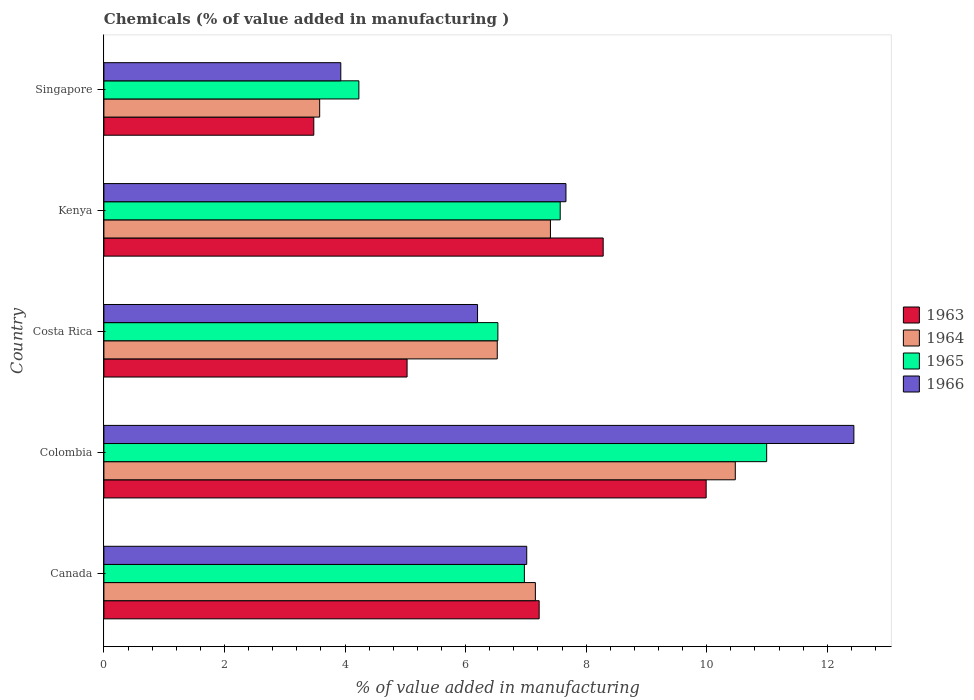How many different coloured bars are there?
Make the answer very short. 4. Are the number of bars on each tick of the Y-axis equal?
Ensure brevity in your answer.  Yes. How many bars are there on the 4th tick from the top?
Give a very brief answer. 4. What is the label of the 1st group of bars from the top?
Give a very brief answer. Singapore. In how many cases, is the number of bars for a given country not equal to the number of legend labels?
Offer a terse response. 0. What is the value added in manufacturing chemicals in 1964 in Kenya?
Offer a terse response. 7.41. Across all countries, what is the maximum value added in manufacturing chemicals in 1966?
Ensure brevity in your answer.  12.44. Across all countries, what is the minimum value added in manufacturing chemicals in 1963?
Provide a short and direct response. 3.48. In which country was the value added in manufacturing chemicals in 1965 minimum?
Your answer should be very brief. Singapore. What is the total value added in manufacturing chemicals in 1963 in the graph?
Give a very brief answer. 34.01. What is the difference between the value added in manufacturing chemicals in 1964 in Canada and that in Costa Rica?
Your answer should be compact. 0.63. What is the difference between the value added in manufacturing chemicals in 1963 in Colombia and the value added in manufacturing chemicals in 1965 in Canada?
Make the answer very short. 3.02. What is the average value added in manufacturing chemicals in 1964 per country?
Make the answer very short. 7.03. What is the difference between the value added in manufacturing chemicals in 1963 and value added in manufacturing chemicals in 1964 in Canada?
Your answer should be very brief. 0.06. In how many countries, is the value added in manufacturing chemicals in 1966 greater than 4 %?
Provide a succinct answer. 4. What is the ratio of the value added in manufacturing chemicals in 1966 in Costa Rica to that in Kenya?
Give a very brief answer. 0.81. Is the value added in manufacturing chemicals in 1964 in Canada less than that in Singapore?
Ensure brevity in your answer.  No. What is the difference between the highest and the second highest value added in manufacturing chemicals in 1963?
Ensure brevity in your answer.  1.71. What is the difference between the highest and the lowest value added in manufacturing chemicals in 1963?
Your response must be concise. 6.51. Is the sum of the value added in manufacturing chemicals in 1966 in Canada and Kenya greater than the maximum value added in manufacturing chemicals in 1963 across all countries?
Offer a terse response. Yes. Is it the case that in every country, the sum of the value added in manufacturing chemicals in 1963 and value added in manufacturing chemicals in 1965 is greater than the sum of value added in manufacturing chemicals in 1966 and value added in manufacturing chemicals in 1964?
Provide a succinct answer. No. What does the 2nd bar from the top in Canada represents?
Your answer should be very brief. 1965. What does the 4th bar from the bottom in Costa Rica represents?
Give a very brief answer. 1966. How many bars are there?
Your answer should be very brief. 20. How many countries are there in the graph?
Ensure brevity in your answer.  5. Are the values on the major ticks of X-axis written in scientific E-notation?
Keep it short and to the point. No. Does the graph contain any zero values?
Give a very brief answer. No. How are the legend labels stacked?
Make the answer very short. Vertical. What is the title of the graph?
Ensure brevity in your answer.  Chemicals (% of value added in manufacturing ). Does "1972" appear as one of the legend labels in the graph?
Your answer should be very brief. No. What is the label or title of the X-axis?
Keep it short and to the point. % of value added in manufacturing. What is the % of value added in manufacturing in 1963 in Canada?
Keep it short and to the point. 7.22. What is the % of value added in manufacturing in 1964 in Canada?
Your response must be concise. 7.16. What is the % of value added in manufacturing in 1965 in Canada?
Give a very brief answer. 6.98. What is the % of value added in manufacturing in 1966 in Canada?
Provide a short and direct response. 7.01. What is the % of value added in manufacturing in 1963 in Colombia?
Make the answer very short. 9.99. What is the % of value added in manufacturing in 1964 in Colombia?
Keep it short and to the point. 10.47. What is the % of value added in manufacturing of 1965 in Colombia?
Make the answer very short. 10.99. What is the % of value added in manufacturing in 1966 in Colombia?
Your answer should be compact. 12.44. What is the % of value added in manufacturing of 1963 in Costa Rica?
Provide a short and direct response. 5.03. What is the % of value added in manufacturing of 1964 in Costa Rica?
Keep it short and to the point. 6.53. What is the % of value added in manufacturing of 1965 in Costa Rica?
Your response must be concise. 6.54. What is the % of value added in manufacturing of 1966 in Costa Rica?
Make the answer very short. 6.2. What is the % of value added in manufacturing in 1963 in Kenya?
Keep it short and to the point. 8.28. What is the % of value added in manufacturing of 1964 in Kenya?
Provide a succinct answer. 7.41. What is the % of value added in manufacturing of 1965 in Kenya?
Provide a short and direct response. 7.57. What is the % of value added in manufacturing in 1966 in Kenya?
Provide a short and direct response. 7.67. What is the % of value added in manufacturing in 1963 in Singapore?
Make the answer very short. 3.48. What is the % of value added in manufacturing in 1964 in Singapore?
Make the answer very short. 3.58. What is the % of value added in manufacturing of 1965 in Singapore?
Your response must be concise. 4.23. What is the % of value added in manufacturing of 1966 in Singapore?
Your answer should be compact. 3.93. Across all countries, what is the maximum % of value added in manufacturing of 1963?
Ensure brevity in your answer.  9.99. Across all countries, what is the maximum % of value added in manufacturing of 1964?
Your answer should be very brief. 10.47. Across all countries, what is the maximum % of value added in manufacturing in 1965?
Your answer should be very brief. 10.99. Across all countries, what is the maximum % of value added in manufacturing of 1966?
Your answer should be very brief. 12.44. Across all countries, what is the minimum % of value added in manufacturing in 1963?
Ensure brevity in your answer.  3.48. Across all countries, what is the minimum % of value added in manufacturing of 1964?
Offer a terse response. 3.58. Across all countries, what is the minimum % of value added in manufacturing in 1965?
Provide a short and direct response. 4.23. Across all countries, what is the minimum % of value added in manufacturing of 1966?
Your response must be concise. 3.93. What is the total % of value added in manufacturing in 1963 in the graph?
Your answer should be compact. 34.01. What is the total % of value added in manufacturing in 1964 in the graph?
Make the answer very short. 35.15. What is the total % of value added in manufacturing of 1965 in the graph?
Provide a succinct answer. 36.31. What is the total % of value added in manufacturing in 1966 in the graph?
Make the answer very short. 37.25. What is the difference between the % of value added in manufacturing of 1963 in Canada and that in Colombia?
Ensure brevity in your answer.  -2.77. What is the difference between the % of value added in manufacturing of 1964 in Canada and that in Colombia?
Ensure brevity in your answer.  -3.32. What is the difference between the % of value added in manufacturing of 1965 in Canada and that in Colombia?
Keep it short and to the point. -4.02. What is the difference between the % of value added in manufacturing of 1966 in Canada and that in Colombia?
Offer a terse response. -5.43. What is the difference between the % of value added in manufacturing of 1963 in Canada and that in Costa Rica?
Provide a short and direct response. 2.19. What is the difference between the % of value added in manufacturing in 1964 in Canada and that in Costa Rica?
Keep it short and to the point. 0.63. What is the difference between the % of value added in manufacturing in 1965 in Canada and that in Costa Rica?
Your answer should be compact. 0.44. What is the difference between the % of value added in manufacturing in 1966 in Canada and that in Costa Rica?
Offer a terse response. 0.82. What is the difference between the % of value added in manufacturing of 1963 in Canada and that in Kenya?
Keep it short and to the point. -1.06. What is the difference between the % of value added in manufacturing of 1964 in Canada and that in Kenya?
Your answer should be compact. -0.25. What is the difference between the % of value added in manufacturing in 1965 in Canada and that in Kenya?
Your answer should be very brief. -0.59. What is the difference between the % of value added in manufacturing in 1966 in Canada and that in Kenya?
Offer a terse response. -0.65. What is the difference between the % of value added in manufacturing in 1963 in Canada and that in Singapore?
Your answer should be very brief. 3.74. What is the difference between the % of value added in manufacturing of 1964 in Canada and that in Singapore?
Provide a short and direct response. 3.58. What is the difference between the % of value added in manufacturing of 1965 in Canada and that in Singapore?
Give a very brief answer. 2.75. What is the difference between the % of value added in manufacturing in 1966 in Canada and that in Singapore?
Provide a succinct answer. 3.08. What is the difference between the % of value added in manufacturing in 1963 in Colombia and that in Costa Rica?
Give a very brief answer. 4.96. What is the difference between the % of value added in manufacturing of 1964 in Colombia and that in Costa Rica?
Offer a very short reply. 3.95. What is the difference between the % of value added in manufacturing of 1965 in Colombia and that in Costa Rica?
Your answer should be compact. 4.46. What is the difference between the % of value added in manufacturing in 1966 in Colombia and that in Costa Rica?
Provide a succinct answer. 6.24. What is the difference between the % of value added in manufacturing in 1963 in Colombia and that in Kenya?
Keep it short and to the point. 1.71. What is the difference between the % of value added in manufacturing in 1964 in Colombia and that in Kenya?
Provide a succinct answer. 3.07. What is the difference between the % of value added in manufacturing of 1965 in Colombia and that in Kenya?
Provide a succinct answer. 3.43. What is the difference between the % of value added in manufacturing in 1966 in Colombia and that in Kenya?
Your answer should be compact. 4.78. What is the difference between the % of value added in manufacturing in 1963 in Colombia and that in Singapore?
Give a very brief answer. 6.51. What is the difference between the % of value added in manufacturing of 1964 in Colombia and that in Singapore?
Keep it short and to the point. 6.89. What is the difference between the % of value added in manufacturing in 1965 in Colombia and that in Singapore?
Keep it short and to the point. 6.76. What is the difference between the % of value added in manufacturing in 1966 in Colombia and that in Singapore?
Your response must be concise. 8.51. What is the difference between the % of value added in manufacturing of 1963 in Costa Rica and that in Kenya?
Make the answer very short. -3.25. What is the difference between the % of value added in manufacturing of 1964 in Costa Rica and that in Kenya?
Your response must be concise. -0.88. What is the difference between the % of value added in manufacturing of 1965 in Costa Rica and that in Kenya?
Your response must be concise. -1.03. What is the difference between the % of value added in manufacturing in 1966 in Costa Rica and that in Kenya?
Offer a very short reply. -1.47. What is the difference between the % of value added in manufacturing in 1963 in Costa Rica and that in Singapore?
Your response must be concise. 1.55. What is the difference between the % of value added in manufacturing of 1964 in Costa Rica and that in Singapore?
Provide a short and direct response. 2.95. What is the difference between the % of value added in manufacturing in 1965 in Costa Rica and that in Singapore?
Your answer should be compact. 2.31. What is the difference between the % of value added in manufacturing in 1966 in Costa Rica and that in Singapore?
Ensure brevity in your answer.  2.27. What is the difference between the % of value added in manufacturing in 1963 in Kenya and that in Singapore?
Give a very brief answer. 4.8. What is the difference between the % of value added in manufacturing in 1964 in Kenya and that in Singapore?
Provide a succinct answer. 3.83. What is the difference between the % of value added in manufacturing of 1965 in Kenya and that in Singapore?
Ensure brevity in your answer.  3.34. What is the difference between the % of value added in manufacturing of 1966 in Kenya and that in Singapore?
Offer a terse response. 3.74. What is the difference between the % of value added in manufacturing in 1963 in Canada and the % of value added in manufacturing in 1964 in Colombia?
Provide a short and direct response. -3.25. What is the difference between the % of value added in manufacturing of 1963 in Canada and the % of value added in manufacturing of 1965 in Colombia?
Offer a terse response. -3.77. What is the difference between the % of value added in manufacturing of 1963 in Canada and the % of value added in manufacturing of 1966 in Colombia?
Offer a very short reply. -5.22. What is the difference between the % of value added in manufacturing of 1964 in Canada and the % of value added in manufacturing of 1965 in Colombia?
Ensure brevity in your answer.  -3.84. What is the difference between the % of value added in manufacturing in 1964 in Canada and the % of value added in manufacturing in 1966 in Colombia?
Provide a short and direct response. -5.28. What is the difference between the % of value added in manufacturing in 1965 in Canada and the % of value added in manufacturing in 1966 in Colombia?
Offer a very short reply. -5.47. What is the difference between the % of value added in manufacturing of 1963 in Canada and the % of value added in manufacturing of 1964 in Costa Rica?
Ensure brevity in your answer.  0.69. What is the difference between the % of value added in manufacturing in 1963 in Canada and the % of value added in manufacturing in 1965 in Costa Rica?
Your response must be concise. 0.68. What is the difference between the % of value added in manufacturing of 1963 in Canada and the % of value added in manufacturing of 1966 in Costa Rica?
Ensure brevity in your answer.  1.02. What is the difference between the % of value added in manufacturing of 1964 in Canada and the % of value added in manufacturing of 1965 in Costa Rica?
Provide a succinct answer. 0.62. What is the difference between the % of value added in manufacturing of 1964 in Canada and the % of value added in manufacturing of 1966 in Costa Rica?
Your response must be concise. 0.96. What is the difference between the % of value added in manufacturing of 1965 in Canada and the % of value added in manufacturing of 1966 in Costa Rica?
Ensure brevity in your answer.  0.78. What is the difference between the % of value added in manufacturing of 1963 in Canada and the % of value added in manufacturing of 1964 in Kenya?
Give a very brief answer. -0.19. What is the difference between the % of value added in manufacturing in 1963 in Canada and the % of value added in manufacturing in 1965 in Kenya?
Your answer should be very brief. -0.35. What is the difference between the % of value added in manufacturing of 1963 in Canada and the % of value added in manufacturing of 1966 in Kenya?
Offer a terse response. -0.44. What is the difference between the % of value added in manufacturing of 1964 in Canada and the % of value added in manufacturing of 1965 in Kenya?
Provide a succinct answer. -0.41. What is the difference between the % of value added in manufacturing of 1964 in Canada and the % of value added in manufacturing of 1966 in Kenya?
Make the answer very short. -0.51. What is the difference between the % of value added in manufacturing in 1965 in Canada and the % of value added in manufacturing in 1966 in Kenya?
Ensure brevity in your answer.  -0.69. What is the difference between the % of value added in manufacturing of 1963 in Canada and the % of value added in manufacturing of 1964 in Singapore?
Your answer should be very brief. 3.64. What is the difference between the % of value added in manufacturing of 1963 in Canada and the % of value added in manufacturing of 1965 in Singapore?
Your answer should be compact. 2.99. What is the difference between the % of value added in manufacturing of 1963 in Canada and the % of value added in manufacturing of 1966 in Singapore?
Offer a terse response. 3.29. What is the difference between the % of value added in manufacturing of 1964 in Canada and the % of value added in manufacturing of 1965 in Singapore?
Keep it short and to the point. 2.93. What is the difference between the % of value added in manufacturing of 1964 in Canada and the % of value added in manufacturing of 1966 in Singapore?
Offer a very short reply. 3.23. What is the difference between the % of value added in manufacturing of 1965 in Canada and the % of value added in manufacturing of 1966 in Singapore?
Provide a succinct answer. 3.05. What is the difference between the % of value added in manufacturing of 1963 in Colombia and the % of value added in manufacturing of 1964 in Costa Rica?
Offer a very short reply. 3.47. What is the difference between the % of value added in manufacturing of 1963 in Colombia and the % of value added in manufacturing of 1965 in Costa Rica?
Your response must be concise. 3.46. What is the difference between the % of value added in manufacturing of 1963 in Colombia and the % of value added in manufacturing of 1966 in Costa Rica?
Keep it short and to the point. 3.79. What is the difference between the % of value added in manufacturing in 1964 in Colombia and the % of value added in manufacturing in 1965 in Costa Rica?
Provide a succinct answer. 3.94. What is the difference between the % of value added in manufacturing of 1964 in Colombia and the % of value added in manufacturing of 1966 in Costa Rica?
Ensure brevity in your answer.  4.28. What is the difference between the % of value added in manufacturing in 1965 in Colombia and the % of value added in manufacturing in 1966 in Costa Rica?
Give a very brief answer. 4.8. What is the difference between the % of value added in manufacturing in 1963 in Colombia and the % of value added in manufacturing in 1964 in Kenya?
Give a very brief answer. 2.58. What is the difference between the % of value added in manufacturing of 1963 in Colombia and the % of value added in manufacturing of 1965 in Kenya?
Offer a terse response. 2.42. What is the difference between the % of value added in manufacturing of 1963 in Colombia and the % of value added in manufacturing of 1966 in Kenya?
Your response must be concise. 2.33. What is the difference between the % of value added in manufacturing in 1964 in Colombia and the % of value added in manufacturing in 1965 in Kenya?
Offer a terse response. 2.9. What is the difference between the % of value added in manufacturing of 1964 in Colombia and the % of value added in manufacturing of 1966 in Kenya?
Make the answer very short. 2.81. What is the difference between the % of value added in manufacturing in 1965 in Colombia and the % of value added in manufacturing in 1966 in Kenya?
Give a very brief answer. 3.33. What is the difference between the % of value added in manufacturing of 1963 in Colombia and the % of value added in manufacturing of 1964 in Singapore?
Keep it short and to the point. 6.41. What is the difference between the % of value added in manufacturing in 1963 in Colombia and the % of value added in manufacturing in 1965 in Singapore?
Provide a succinct answer. 5.76. What is the difference between the % of value added in manufacturing in 1963 in Colombia and the % of value added in manufacturing in 1966 in Singapore?
Provide a short and direct response. 6.06. What is the difference between the % of value added in manufacturing in 1964 in Colombia and the % of value added in manufacturing in 1965 in Singapore?
Keep it short and to the point. 6.24. What is the difference between the % of value added in manufacturing of 1964 in Colombia and the % of value added in manufacturing of 1966 in Singapore?
Provide a succinct answer. 6.54. What is the difference between the % of value added in manufacturing of 1965 in Colombia and the % of value added in manufacturing of 1966 in Singapore?
Provide a succinct answer. 7.07. What is the difference between the % of value added in manufacturing in 1963 in Costa Rica and the % of value added in manufacturing in 1964 in Kenya?
Your answer should be compact. -2.38. What is the difference between the % of value added in manufacturing in 1963 in Costa Rica and the % of value added in manufacturing in 1965 in Kenya?
Offer a terse response. -2.54. What is the difference between the % of value added in manufacturing of 1963 in Costa Rica and the % of value added in manufacturing of 1966 in Kenya?
Ensure brevity in your answer.  -2.64. What is the difference between the % of value added in manufacturing in 1964 in Costa Rica and the % of value added in manufacturing in 1965 in Kenya?
Your answer should be very brief. -1.04. What is the difference between the % of value added in manufacturing of 1964 in Costa Rica and the % of value added in manufacturing of 1966 in Kenya?
Your response must be concise. -1.14. What is the difference between the % of value added in manufacturing of 1965 in Costa Rica and the % of value added in manufacturing of 1966 in Kenya?
Provide a short and direct response. -1.13. What is the difference between the % of value added in manufacturing in 1963 in Costa Rica and the % of value added in manufacturing in 1964 in Singapore?
Offer a very short reply. 1.45. What is the difference between the % of value added in manufacturing of 1963 in Costa Rica and the % of value added in manufacturing of 1965 in Singapore?
Your answer should be very brief. 0.8. What is the difference between the % of value added in manufacturing in 1963 in Costa Rica and the % of value added in manufacturing in 1966 in Singapore?
Give a very brief answer. 1.1. What is the difference between the % of value added in manufacturing of 1964 in Costa Rica and the % of value added in manufacturing of 1965 in Singapore?
Your answer should be very brief. 2.3. What is the difference between the % of value added in manufacturing in 1964 in Costa Rica and the % of value added in manufacturing in 1966 in Singapore?
Provide a short and direct response. 2.6. What is the difference between the % of value added in manufacturing in 1965 in Costa Rica and the % of value added in manufacturing in 1966 in Singapore?
Your response must be concise. 2.61. What is the difference between the % of value added in manufacturing in 1963 in Kenya and the % of value added in manufacturing in 1964 in Singapore?
Your answer should be very brief. 4.7. What is the difference between the % of value added in manufacturing of 1963 in Kenya and the % of value added in manufacturing of 1965 in Singapore?
Your answer should be very brief. 4.05. What is the difference between the % of value added in manufacturing of 1963 in Kenya and the % of value added in manufacturing of 1966 in Singapore?
Offer a terse response. 4.35. What is the difference between the % of value added in manufacturing of 1964 in Kenya and the % of value added in manufacturing of 1965 in Singapore?
Provide a short and direct response. 3.18. What is the difference between the % of value added in manufacturing in 1964 in Kenya and the % of value added in manufacturing in 1966 in Singapore?
Provide a succinct answer. 3.48. What is the difference between the % of value added in manufacturing of 1965 in Kenya and the % of value added in manufacturing of 1966 in Singapore?
Give a very brief answer. 3.64. What is the average % of value added in manufacturing in 1963 per country?
Offer a terse response. 6.8. What is the average % of value added in manufacturing in 1964 per country?
Give a very brief answer. 7.03. What is the average % of value added in manufacturing in 1965 per country?
Provide a short and direct response. 7.26. What is the average % of value added in manufacturing in 1966 per country?
Offer a terse response. 7.45. What is the difference between the % of value added in manufacturing of 1963 and % of value added in manufacturing of 1964 in Canada?
Your answer should be compact. 0.06. What is the difference between the % of value added in manufacturing in 1963 and % of value added in manufacturing in 1965 in Canada?
Your response must be concise. 0.25. What is the difference between the % of value added in manufacturing in 1963 and % of value added in manufacturing in 1966 in Canada?
Your response must be concise. 0.21. What is the difference between the % of value added in manufacturing in 1964 and % of value added in manufacturing in 1965 in Canada?
Provide a short and direct response. 0.18. What is the difference between the % of value added in manufacturing of 1964 and % of value added in manufacturing of 1966 in Canada?
Provide a short and direct response. 0.14. What is the difference between the % of value added in manufacturing of 1965 and % of value added in manufacturing of 1966 in Canada?
Offer a very short reply. -0.04. What is the difference between the % of value added in manufacturing of 1963 and % of value added in manufacturing of 1964 in Colombia?
Give a very brief answer. -0.48. What is the difference between the % of value added in manufacturing in 1963 and % of value added in manufacturing in 1965 in Colombia?
Offer a terse response. -1. What is the difference between the % of value added in manufacturing of 1963 and % of value added in manufacturing of 1966 in Colombia?
Your answer should be compact. -2.45. What is the difference between the % of value added in manufacturing of 1964 and % of value added in manufacturing of 1965 in Colombia?
Offer a very short reply. -0.52. What is the difference between the % of value added in manufacturing in 1964 and % of value added in manufacturing in 1966 in Colombia?
Your response must be concise. -1.97. What is the difference between the % of value added in manufacturing of 1965 and % of value added in manufacturing of 1966 in Colombia?
Give a very brief answer. -1.45. What is the difference between the % of value added in manufacturing of 1963 and % of value added in manufacturing of 1964 in Costa Rica?
Make the answer very short. -1.5. What is the difference between the % of value added in manufacturing of 1963 and % of value added in manufacturing of 1965 in Costa Rica?
Offer a very short reply. -1.51. What is the difference between the % of value added in manufacturing in 1963 and % of value added in manufacturing in 1966 in Costa Rica?
Make the answer very short. -1.17. What is the difference between the % of value added in manufacturing in 1964 and % of value added in manufacturing in 1965 in Costa Rica?
Your response must be concise. -0.01. What is the difference between the % of value added in manufacturing in 1964 and % of value added in manufacturing in 1966 in Costa Rica?
Provide a short and direct response. 0.33. What is the difference between the % of value added in manufacturing of 1965 and % of value added in manufacturing of 1966 in Costa Rica?
Provide a succinct answer. 0.34. What is the difference between the % of value added in manufacturing in 1963 and % of value added in manufacturing in 1964 in Kenya?
Give a very brief answer. 0.87. What is the difference between the % of value added in manufacturing in 1963 and % of value added in manufacturing in 1965 in Kenya?
Provide a succinct answer. 0.71. What is the difference between the % of value added in manufacturing in 1963 and % of value added in manufacturing in 1966 in Kenya?
Keep it short and to the point. 0.62. What is the difference between the % of value added in manufacturing of 1964 and % of value added in manufacturing of 1965 in Kenya?
Make the answer very short. -0.16. What is the difference between the % of value added in manufacturing in 1964 and % of value added in manufacturing in 1966 in Kenya?
Offer a very short reply. -0.26. What is the difference between the % of value added in manufacturing of 1965 and % of value added in manufacturing of 1966 in Kenya?
Your answer should be compact. -0.1. What is the difference between the % of value added in manufacturing in 1963 and % of value added in manufacturing in 1964 in Singapore?
Your answer should be very brief. -0.1. What is the difference between the % of value added in manufacturing in 1963 and % of value added in manufacturing in 1965 in Singapore?
Provide a short and direct response. -0.75. What is the difference between the % of value added in manufacturing of 1963 and % of value added in manufacturing of 1966 in Singapore?
Your response must be concise. -0.45. What is the difference between the % of value added in manufacturing of 1964 and % of value added in manufacturing of 1965 in Singapore?
Ensure brevity in your answer.  -0.65. What is the difference between the % of value added in manufacturing in 1964 and % of value added in manufacturing in 1966 in Singapore?
Keep it short and to the point. -0.35. What is the difference between the % of value added in manufacturing in 1965 and % of value added in manufacturing in 1966 in Singapore?
Your answer should be very brief. 0.3. What is the ratio of the % of value added in manufacturing of 1963 in Canada to that in Colombia?
Provide a succinct answer. 0.72. What is the ratio of the % of value added in manufacturing of 1964 in Canada to that in Colombia?
Your answer should be very brief. 0.68. What is the ratio of the % of value added in manufacturing in 1965 in Canada to that in Colombia?
Your answer should be very brief. 0.63. What is the ratio of the % of value added in manufacturing in 1966 in Canada to that in Colombia?
Keep it short and to the point. 0.56. What is the ratio of the % of value added in manufacturing in 1963 in Canada to that in Costa Rica?
Keep it short and to the point. 1.44. What is the ratio of the % of value added in manufacturing of 1964 in Canada to that in Costa Rica?
Your response must be concise. 1.1. What is the ratio of the % of value added in manufacturing in 1965 in Canada to that in Costa Rica?
Make the answer very short. 1.07. What is the ratio of the % of value added in manufacturing of 1966 in Canada to that in Costa Rica?
Provide a succinct answer. 1.13. What is the ratio of the % of value added in manufacturing in 1963 in Canada to that in Kenya?
Make the answer very short. 0.87. What is the ratio of the % of value added in manufacturing of 1964 in Canada to that in Kenya?
Offer a terse response. 0.97. What is the ratio of the % of value added in manufacturing of 1965 in Canada to that in Kenya?
Keep it short and to the point. 0.92. What is the ratio of the % of value added in manufacturing of 1966 in Canada to that in Kenya?
Provide a succinct answer. 0.92. What is the ratio of the % of value added in manufacturing in 1963 in Canada to that in Singapore?
Ensure brevity in your answer.  2.07. What is the ratio of the % of value added in manufacturing of 1964 in Canada to that in Singapore?
Give a very brief answer. 2. What is the ratio of the % of value added in manufacturing in 1965 in Canada to that in Singapore?
Provide a succinct answer. 1.65. What is the ratio of the % of value added in manufacturing of 1966 in Canada to that in Singapore?
Your answer should be very brief. 1.78. What is the ratio of the % of value added in manufacturing in 1963 in Colombia to that in Costa Rica?
Keep it short and to the point. 1.99. What is the ratio of the % of value added in manufacturing of 1964 in Colombia to that in Costa Rica?
Give a very brief answer. 1.61. What is the ratio of the % of value added in manufacturing in 1965 in Colombia to that in Costa Rica?
Ensure brevity in your answer.  1.68. What is the ratio of the % of value added in manufacturing in 1966 in Colombia to that in Costa Rica?
Ensure brevity in your answer.  2.01. What is the ratio of the % of value added in manufacturing of 1963 in Colombia to that in Kenya?
Provide a succinct answer. 1.21. What is the ratio of the % of value added in manufacturing of 1964 in Colombia to that in Kenya?
Your answer should be compact. 1.41. What is the ratio of the % of value added in manufacturing of 1965 in Colombia to that in Kenya?
Offer a very short reply. 1.45. What is the ratio of the % of value added in manufacturing in 1966 in Colombia to that in Kenya?
Your answer should be very brief. 1.62. What is the ratio of the % of value added in manufacturing in 1963 in Colombia to that in Singapore?
Ensure brevity in your answer.  2.87. What is the ratio of the % of value added in manufacturing of 1964 in Colombia to that in Singapore?
Ensure brevity in your answer.  2.93. What is the ratio of the % of value added in manufacturing of 1965 in Colombia to that in Singapore?
Give a very brief answer. 2.6. What is the ratio of the % of value added in manufacturing in 1966 in Colombia to that in Singapore?
Make the answer very short. 3.17. What is the ratio of the % of value added in manufacturing in 1963 in Costa Rica to that in Kenya?
Provide a succinct answer. 0.61. What is the ratio of the % of value added in manufacturing of 1964 in Costa Rica to that in Kenya?
Provide a succinct answer. 0.88. What is the ratio of the % of value added in manufacturing in 1965 in Costa Rica to that in Kenya?
Give a very brief answer. 0.86. What is the ratio of the % of value added in manufacturing of 1966 in Costa Rica to that in Kenya?
Offer a terse response. 0.81. What is the ratio of the % of value added in manufacturing of 1963 in Costa Rica to that in Singapore?
Ensure brevity in your answer.  1.44. What is the ratio of the % of value added in manufacturing of 1964 in Costa Rica to that in Singapore?
Provide a short and direct response. 1.82. What is the ratio of the % of value added in manufacturing of 1965 in Costa Rica to that in Singapore?
Provide a succinct answer. 1.55. What is the ratio of the % of value added in manufacturing in 1966 in Costa Rica to that in Singapore?
Offer a terse response. 1.58. What is the ratio of the % of value added in manufacturing in 1963 in Kenya to that in Singapore?
Ensure brevity in your answer.  2.38. What is the ratio of the % of value added in manufacturing of 1964 in Kenya to that in Singapore?
Your answer should be very brief. 2.07. What is the ratio of the % of value added in manufacturing of 1965 in Kenya to that in Singapore?
Provide a short and direct response. 1.79. What is the ratio of the % of value added in manufacturing of 1966 in Kenya to that in Singapore?
Offer a terse response. 1.95. What is the difference between the highest and the second highest % of value added in manufacturing of 1963?
Provide a succinct answer. 1.71. What is the difference between the highest and the second highest % of value added in manufacturing in 1964?
Give a very brief answer. 3.07. What is the difference between the highest and the second highest % of value added in manufacturing of 1965?
Provide a succinct answer. 3.43. What is the difference between the highest and the second highest % of value added in manufacturing in 1966?
Make the answer very short. 4.78. What is the difference between the highest and the lowest % of value added in manufacturing in 1963?
Your answer should be compact. 6.51. What is the difference between the highest and the lowest % of value added in manufacturing in 1964?
Provide a short and direct response. 6.89. What is the difference between the highest and the lowest % of value added in manufacturing of 1965?
Offer a very short reply. 6.76. What is the difference between the highest and the lowest % of value added in manufacturing of 1966?
Provide a succinct answer. 8.51. 